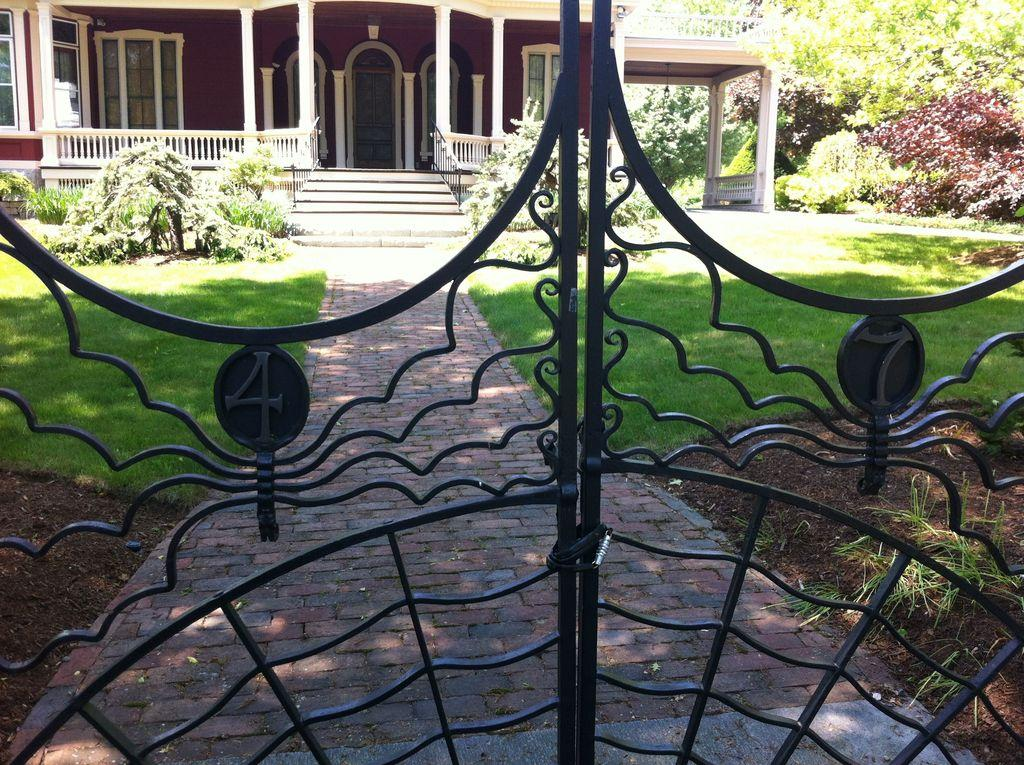What is located in the foreground of the image? There is a gate in the foreground of the image. What type of vegetation can be seen in the foreground of the image? There is grass in the foreground of the image. What other objects are present in the foreground of the image? There are houseplants in the foreground of the image. What can be seen in the background of the image? There is a building and windows visible in the background of the image. What is the weather like in the image? The image was taken during a sunny day. Can you see the father holding a yoke in the image? There is no father or yoke present in the image. Are there any mittens visible in the image? There are no mittens present in the image. 